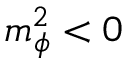<formula> <loc_0><loc_0><loc_500><loc_500>m _ { \phi } ^ { 2 } < 0</formula> 